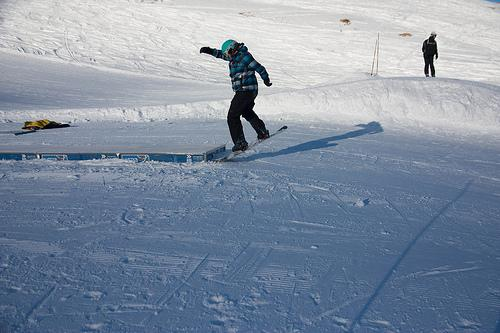Based on this image, what can you infer about people's interests and hobbies? The people depicted in this scene are interested in winter sports such as snowboarding and skiing, and enjoy spending time outdoors in cold and snowy environments. Evaluate the overall quality of the image, considering aspects such as sharpness, composition, and lighting. The image has a good composition with focus on the snowboarding person, well-distributed objects, and clear lighting, but object sharpness could be improved for better clarity. Count the people and the other main objects in the image. There are 4 people, 1 snowboard, 1 helmet, 1 ramp, 1 abandoned coat, shoe prints, multiple snowy hill sides, and some sticks. Please enumerate activities and objects you can find in this image. Snowboarding, skiing, watching, jumping, standing; person, snowboard, coat, helmet, pants, clouds, ramp, snow drift, shoe prints, hillside, shadow, sticks. Assess the sentiment or mood conveyed by this image. The image conveys a positive and adventurous mood, with people enjoying winter sports and activities in a snowy, picturesque environment. Considering the elements in the image, in what season is the activity happening? The activity is happening during winter, due to the presence of snow, winter sports like snowboarding and skiing, and people wearing warm clothing. Identify and describe the color of the snow in the image. The snow in this image is a blueish-white color, giving it an appealing and fresh look typical of a cold winter day. What is the central object in this image and what is happening surrounding the object? The central object is a person on a snowboard; the person is wearing a blue helmet, a multicolored coat, and black pants, while others watch and there are ski ramps and snowy hills around. Provide a caption for this winter scene photo. A snowboarder in colorful gear enjoys the mountain slopes, surrounded by snowy hillsides, ramps, and onlookers. Analyze the interaction between snowboarding person and others in the image. The snowboarding person is performing and practicing their moves, while other people observe and stand nearby wearing black clothes. 